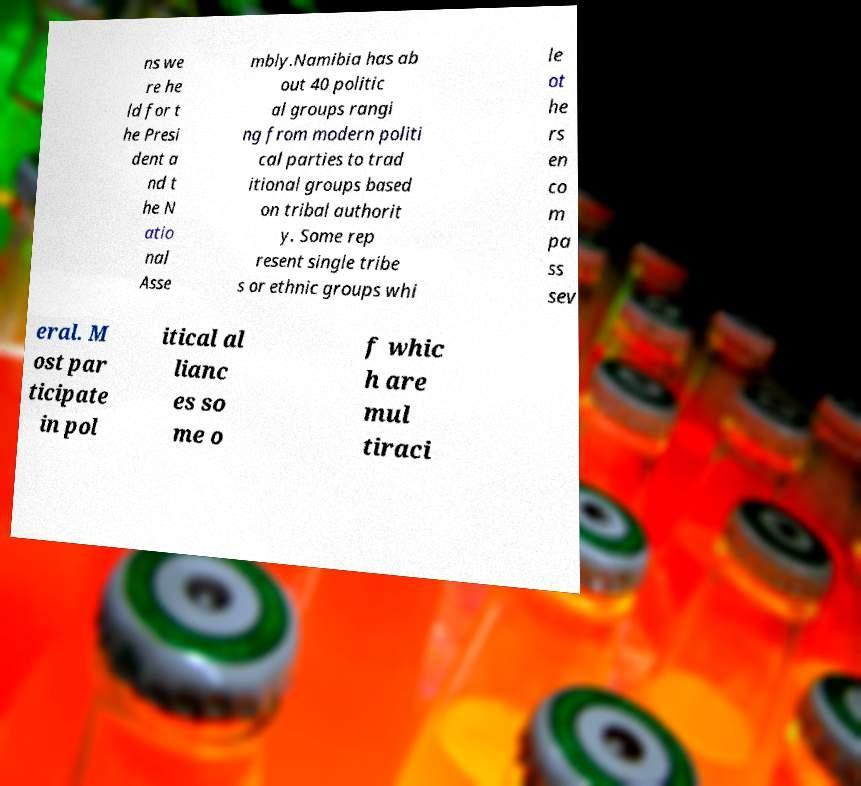There's text embedded in this image that I need extracted. Can you transcribe it verbatim? ns we re he ld for t he Presi dent a nd t he N atio nal Asse mbly.Namibia has ab out 40 politic al groups rangi ng from modern politi cal parties to trad itional groups based on tribal authorit y. Some rep resent single tribe s or ethnic groups whi le ot he rs en co m pa ss sev eral. M ost par ticipate in pol itical al lianc es so me o f whic h are mul tiraci 